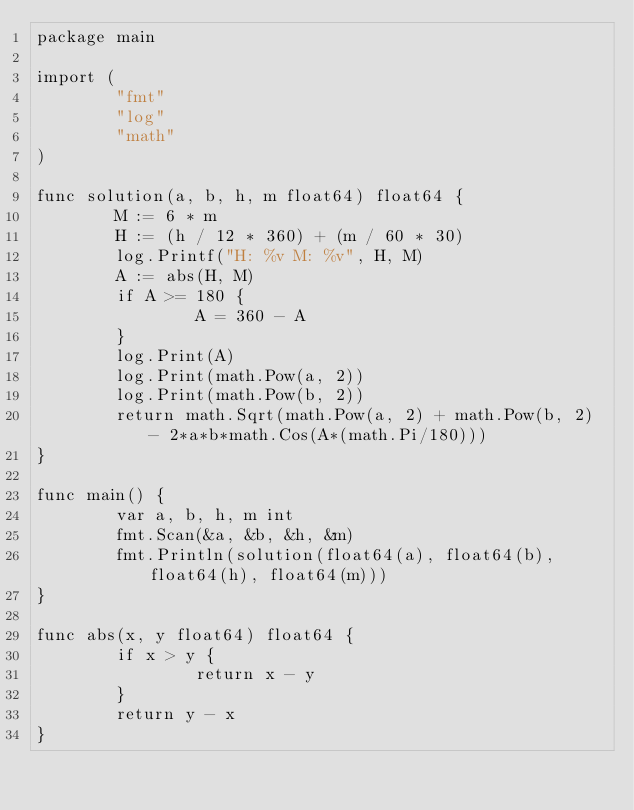<code> <loc_0><loc_0><loc_500><loc_500><_Go_>package main

import (
        "fmt"
        "log"
        "math"
)

func solution(a, b, h, m float64) float64 {
        M := 6 * m
        H := (h / 12 * 360) + (m / 60 * 30)
        log.Printf("H: %v M: %v", H, M)
        A := abs(H, M)
        if A >= 180 {
                A = 360 - A
        }
        log.Print(A)
        log.Print(math.Pow(a, 2))
        log.Print(math.Pow(b, 2))
        return math.Sqrt(math.Pow(a, 2) + math.Pow(b, 2) - 2*a*b*math.Cos(A*(math.Pi/180)))
}

func main() {
        var a, b, h, m int
        fmt.Scan(&a, &b, &h, &m)
        fmt.Println(solution(float64(a), float64(b), float64(h), float64(m)))
}

func abs(x, y float64) float64 {
        if x > y {
                return x - y
        }
        return y - x
}</code> 